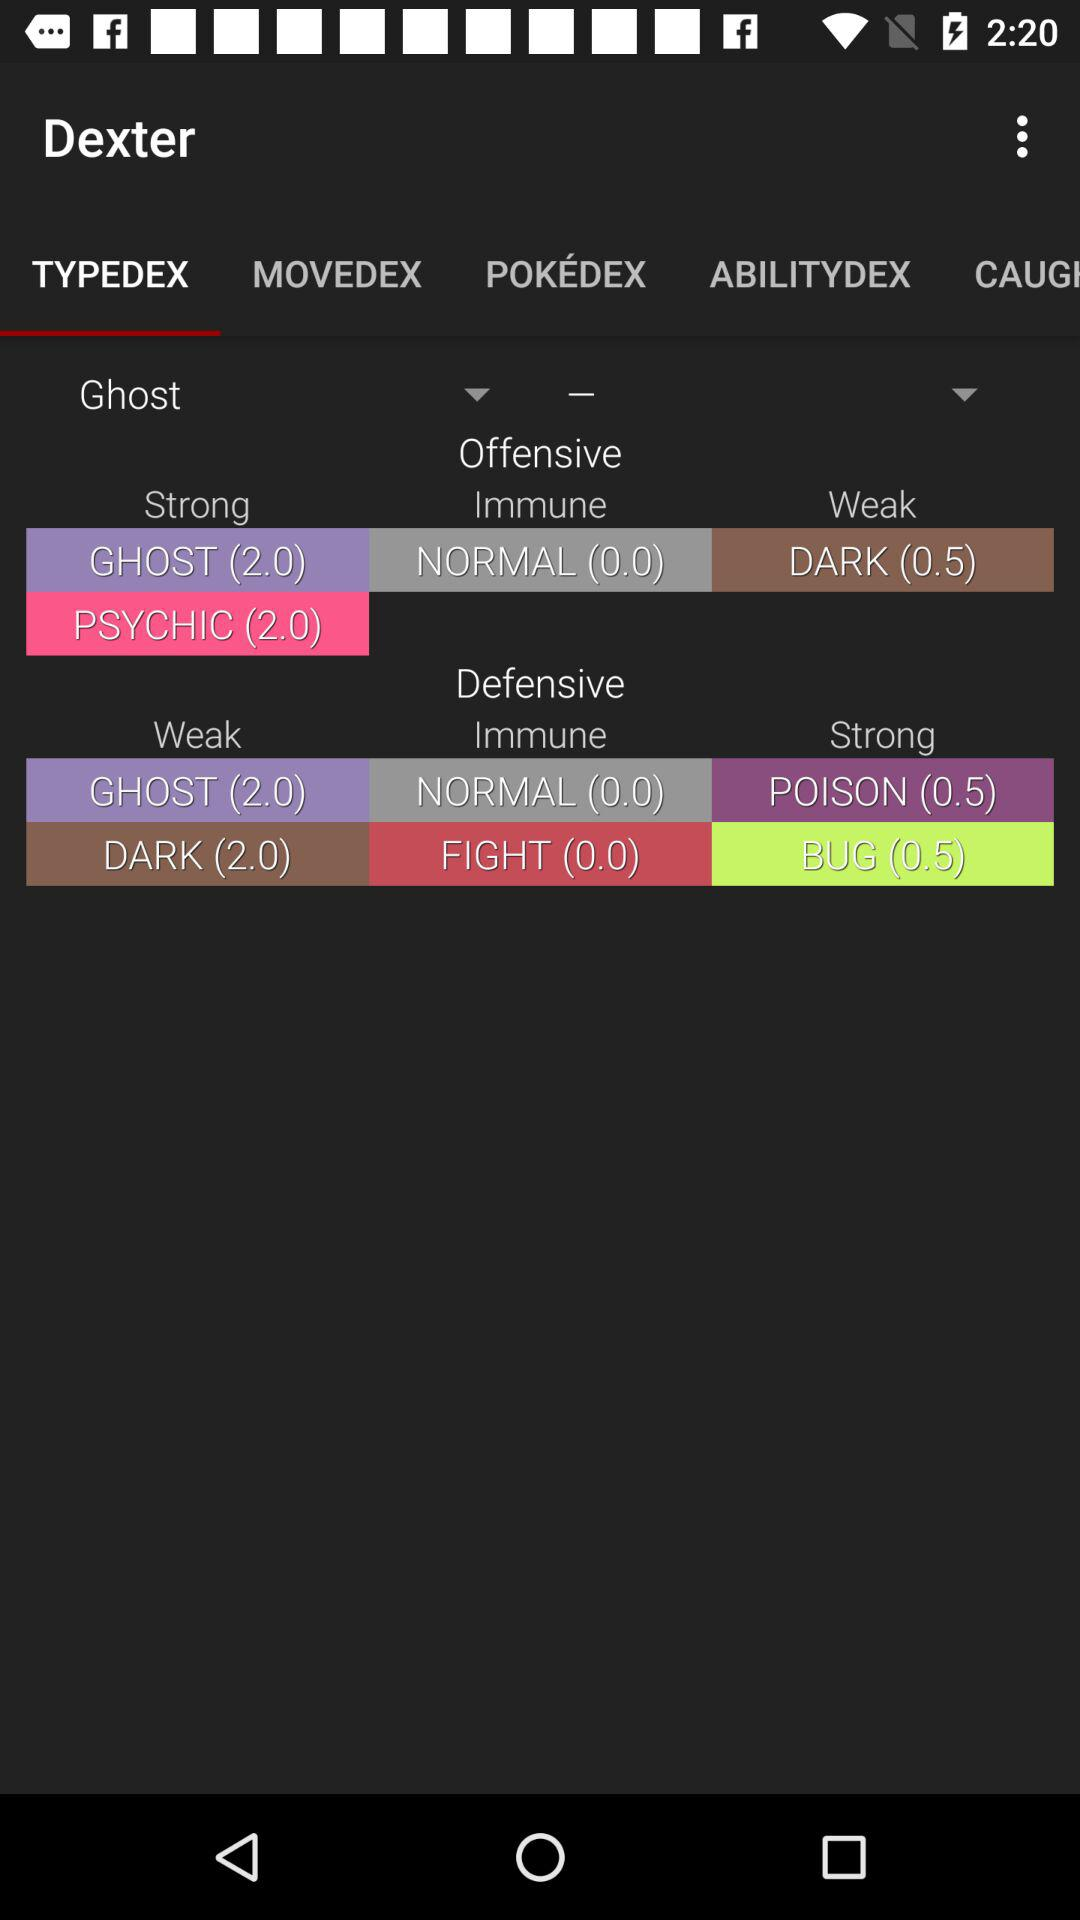How many ghosts are there?
When the provided information is insufficient, respond with <no answer>. <no answer> 